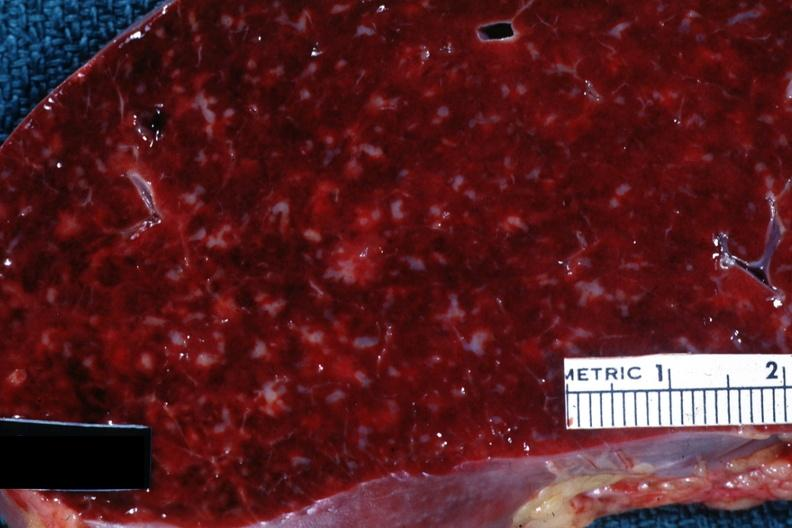s hematologic present?
Answer the question using a single word or phrase. Yes 